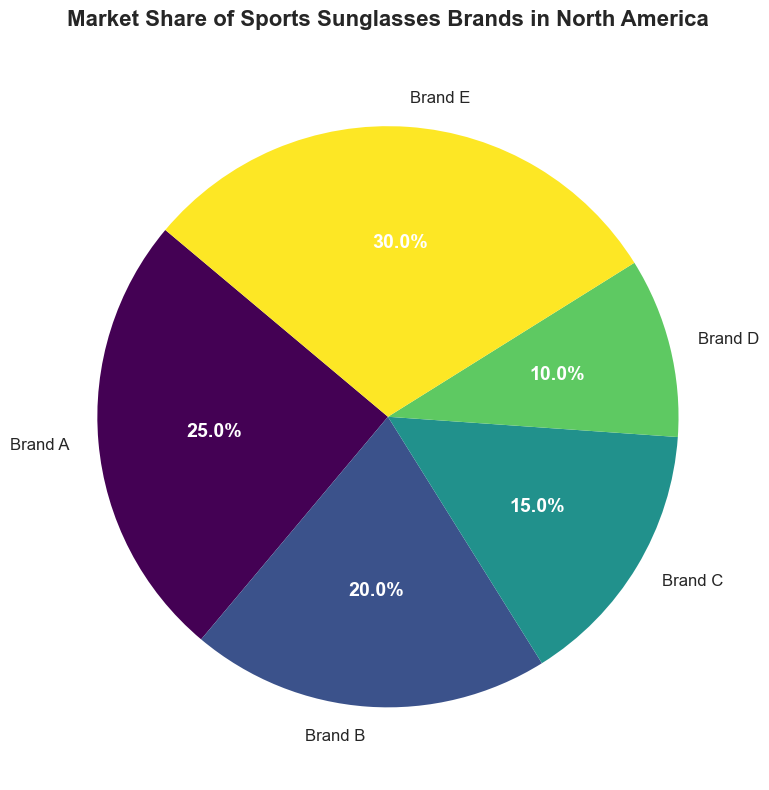What is the market share percentage of Brand E in North America? The pie chart for North America will show different segments representing various brands. Locate the segment labeled "Brand E" and note its percentage.
Answer: 30% Which brand has the smallest market share in Europe? Observe the pie chart for Europe and identify the segment with the smallest percentage. This is the brand with the smallest market share.
Answer: Brand C What is the difference in market share between Brand A and Brand B in Asia? For the Asia region pie chart, find the segments for Brand A and Brand B and note their percentages. Subtract the market share of Brand B from Brand A.
Answer: 15% In which region does Brand D have the highest market share? Look at all the pie charts and the segments labeled "Brand D." Compare the percentages of each segment across different regions.
Answer: Europe How does the market share of Brand B in South America compare to that in Africa? Check the pie charts for South America and Africa, then compare the percentage segments labeled "Brand B" in both regions.
Answer: South America is larger What is the total market share of Brands A, B, and C combined in Oceania? Identify the segments for Brands A, B, and C in the Oceania pie chart, then add their percentages.
Answer: 64% Which brand has equal market share in both North America and Oceania? Find the segments of each brand in both the North America and Oceania pie charts and compare their percentages to identify any equal values.
Answer: Brand B Is Brand E more dominant in Asia or South America? Compare the market share percentages of Brand E in the pie charts for Asia and South America.
Answer: Asia What is the average market share of Brand A across all regions? Sum the market share percentages of Brand A in each pie chart and divide by the number of regions.
Answer: 24.17% Which brand has the highest market share across all regions? For each region's pie chart, identify the brand with the highest segment percentage, then determine which brand appears most frequently.
Answer: Brand E 